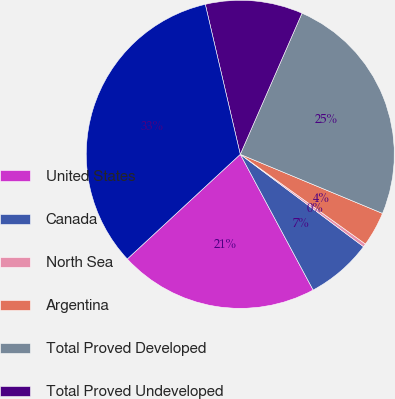Convert chart. <chart><loc_0><loc_0><loc_500><loc_500><pie_chart><fcel>United States<fcel>Canada<fcel>North Sea<fcel>Argentina<fcel>Total Proved Developed<fcel>Total Proved Undeveloped<fcel>TOTAL PROVED<nl><fcel>20.95%<fcel>6.92%<fcel>0.34%<fcel>3.63%<fcel>24.7%<fcel>10.21%<fcel>33.24%<nl></chart> 